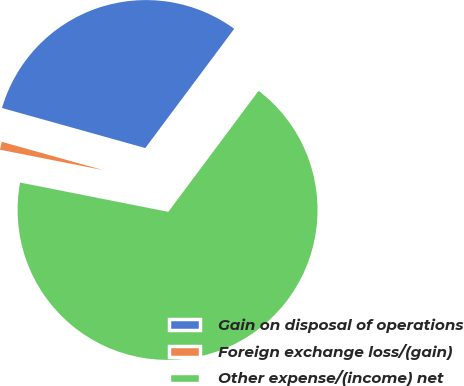Convert chart. <chart><loc_0><loc_0><loc_500><loc_500><pie_chart><fcel>Gain on disposal of operations<fcel>Foreign exchange loss/(gain)<fcel>Other expense/(income) net<nl><fcel>30.86%<fcel>1.23%<fcel>67.9%<nl></chart> 